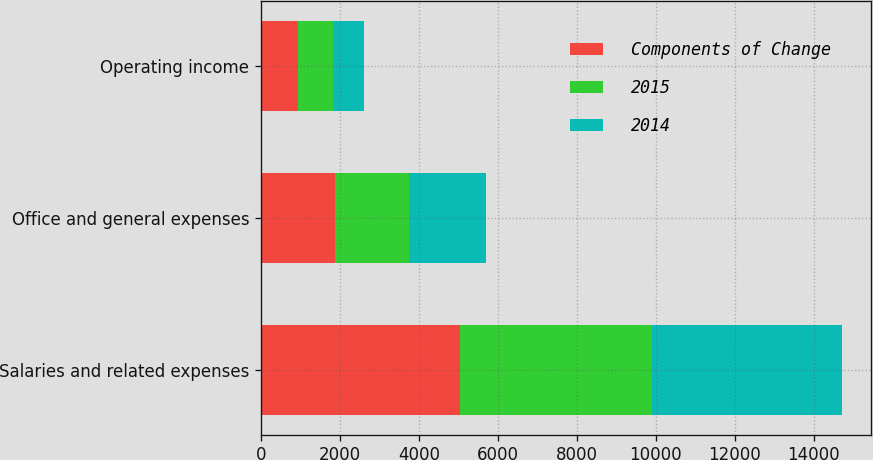Convert chart to OTSL. <chart><loc_0><loc_0><loc_500><loc_500><stacked_bar_chart><ecel><fcel>Salaries and related expenses<fcel>Office and general expenses<fcel>Operating income<nl><fcel>Components of Change<fcel>5038.1<fcel>1870.5<fcel>938<nl><fcel>2015<fcel>4857.7<fcel>1884.2<fcel>871.9<nl><fcel>2014<fcel>4820.4<fcel>1928.3<fcel>788.4<nl></chart> 